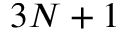Convert formula to latex. <formula><loc_0><loc_0><loc_500><loc_500>3 N + 1</formula> 